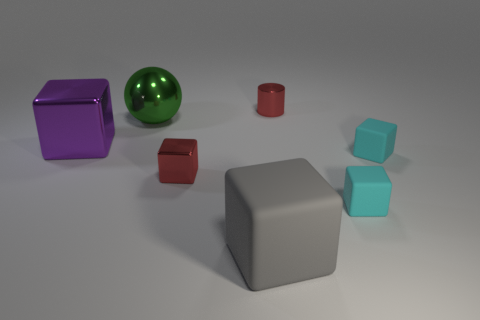Subtract all big matte blocks. How many blocks are left? 4 Subtract all spheres. How many objects are left? 6 Add 2 large green objects. How many objects exist? 9 Subtract 5 blocks. How many blocks are left? 0 Add 6 tiny brown metallic blocks. How many tiny brown metallic blocks exist? 6 Subtract all gray blocks. How many blocks are left? 4 Subtract 0 gray spheres. How many objects are left? 7 Subtract all purple cubes. Subtract all cyan cylinders. How many cubes are left? 4 Subtract all blue cylinders. How many cyan blocks are left? 2 Subtract all small cubes. Subtract all large green spheres. How many objects are left? 3 